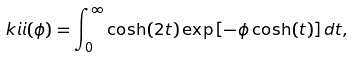Convert formula to latex. <formula><loc_0><loc_0><loc_500><loc_500>\ k i i ( \phi ) = \int _ { 0 } ^ { \infty } \cosh ( 2 t ) \exp \left [ - \phi \cosh ( t ) \right ] d t ,</formula> 